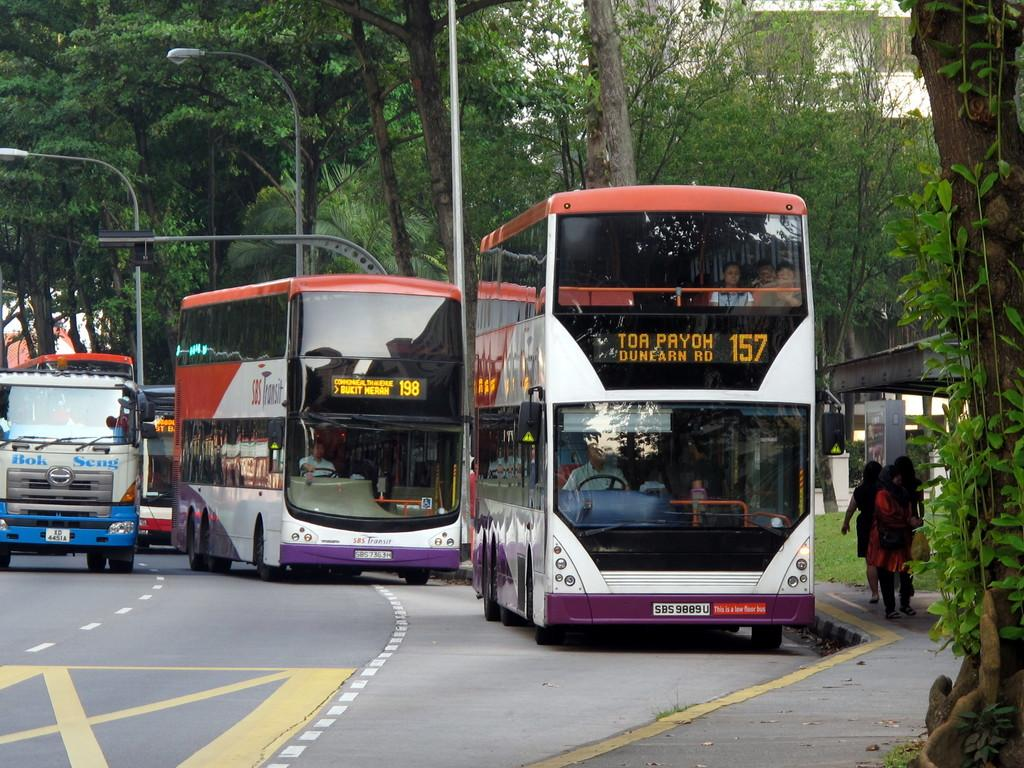What type of vehicles are parked on the road in the image? There are buses parked on the road in the image. What are the people in the buses doing? People are sitting in the buses. Where are the people waiting for the bus located? There are people standing at a bus stop. What type of vegetation can be seen in the image? Trees are present in the image. What type of cub can be seen playing with the train in the image? There is no cub or train present in the image; it features buses parked on the road and people at a bus stop. What order are the people waiting for the bus following in the image? There is no indication of any specific order in which the people are waiting for the bus in the image. 